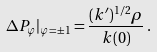<formula> <loc_0><loc_0><loc_500><loc_500>\Delta P _ { \varphi } | _ { \varphi = \pm 1 } = \frac { ( k ^ { \prime } ) ^ { 1 / 2 } \rho } { k ( 0 ) } \, .</formula> 